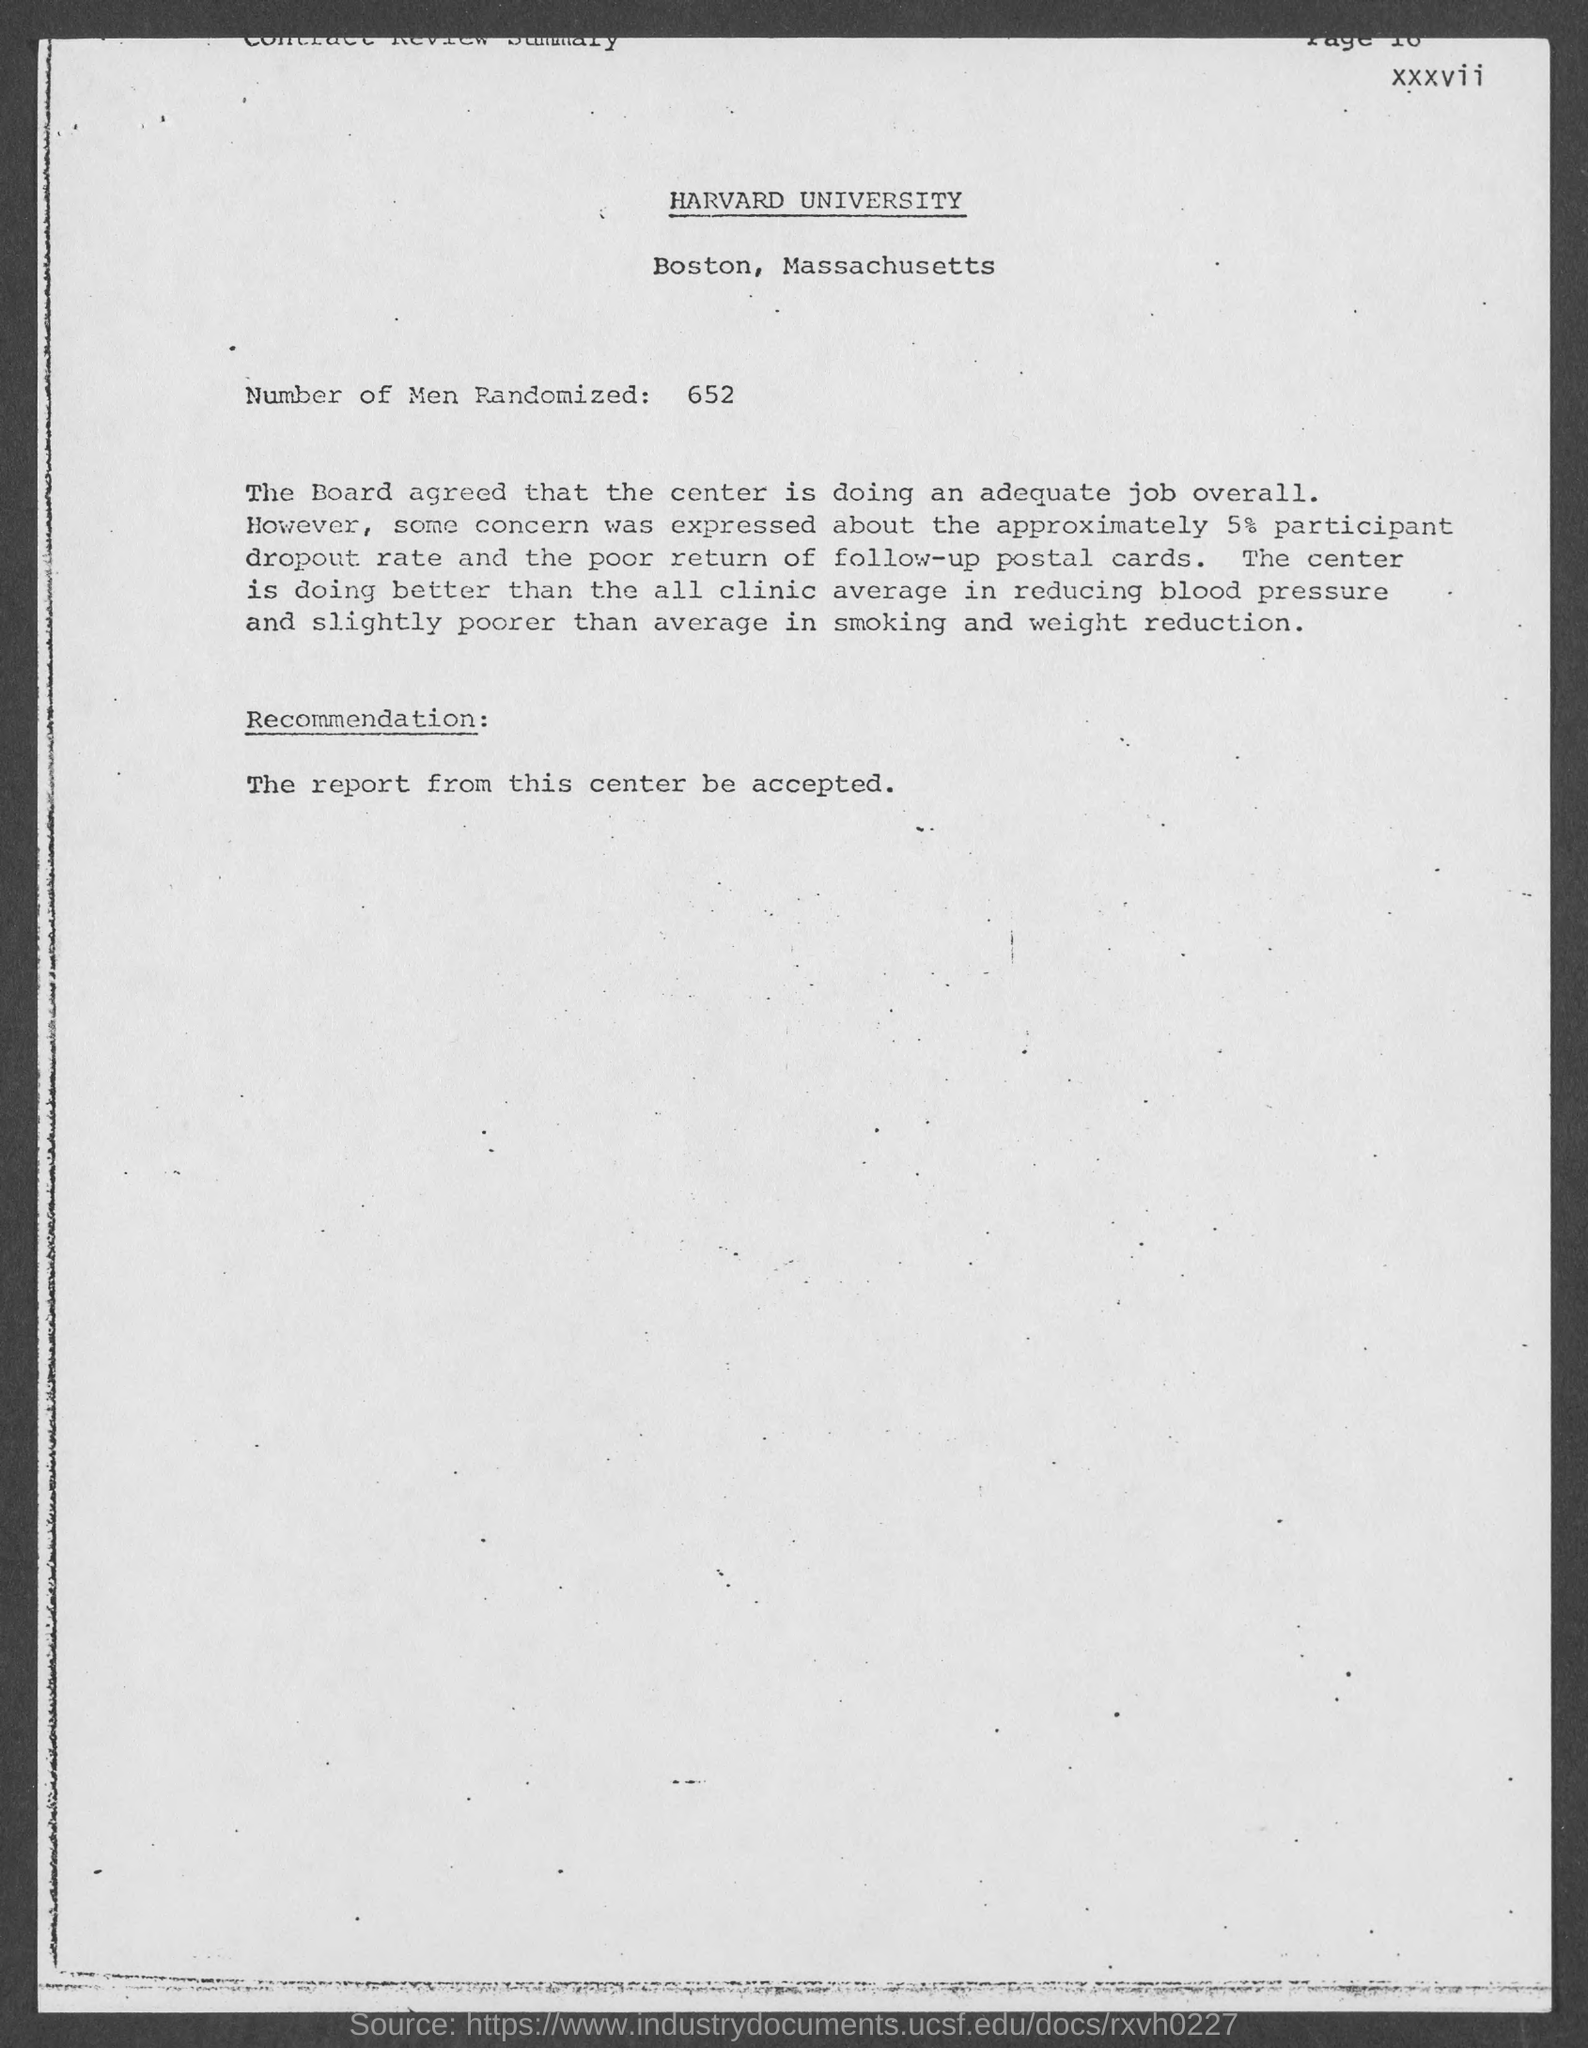Which university is mentioned in this document?
Make the answer very short. HARVARD UNIVERSITY. Where "Harvard University" is located?
Provide a short and direct response. Boston. What are the "Number of Men Randomized" ?
Keep it short and to the point. 652. What is the dropout rate and the poor return of follow-up postal cards?
Provide a succinct answer. 5%. 